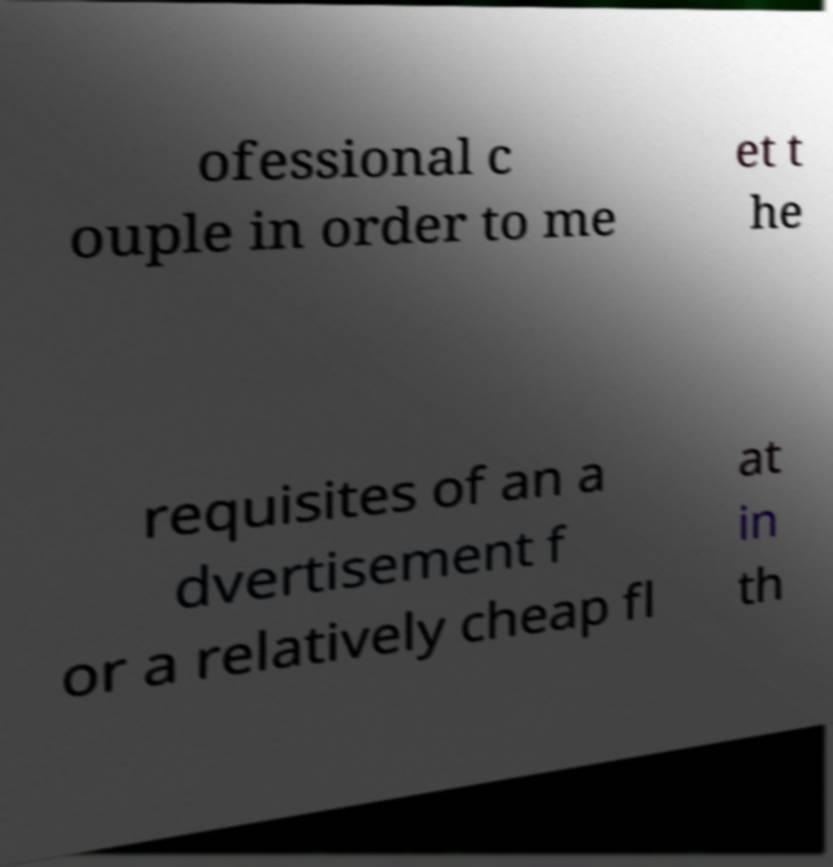Could you extract and type out the text from this image? ofessional c ouple in order to me et t he requisites of an a dvertisement f or a relatively cheap fl at in th 